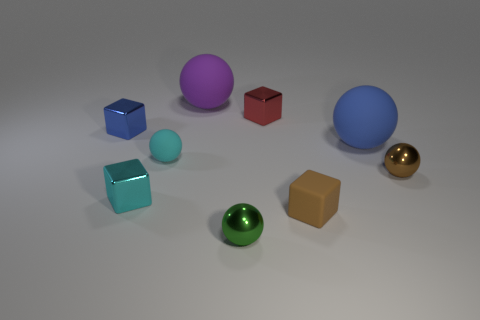What is the size of the brown cube that is the same material as the big purple sphere?
Offer a very short reply. Small. What number of tiny green shiny things have the same shape as the tiny blue thing?
Your answer should be very brief. 0. Is the number of tiny cyan rubber spheres that are behind the blue rubber object greater than the number of tiny red blocks to the right of the small brown shiny sphere?
Provide a short and direct response. No. There is a matte cube; is it the same color as the tiny ball right of the green shiny thing?
Keep it short and to the point. Yes. What is the material of the cyan sphere that is the same size as the brown metal sphere?
Keep it short and to the point. Rubber. How many things are cyan metal spheres or shiny balls that are behind the cyan metal object?
Offer a terse response. 1. There is a blue shiny object; is it the same size as the metallic sphere that is on the right side of the small brown rubber cube?
Offer a very short reply. Yes. What number of spheres are either tiny brown metal things or big blue shiny things?
Your response must be concise. 1. How many small things are both in front of the cyan metallic cube and behind the green metallic thing?
Keep it short and to the point. 1. The small cyan thing that is behind the brown metallic ball has what shape?
Your answer should be compact. Sphere. 